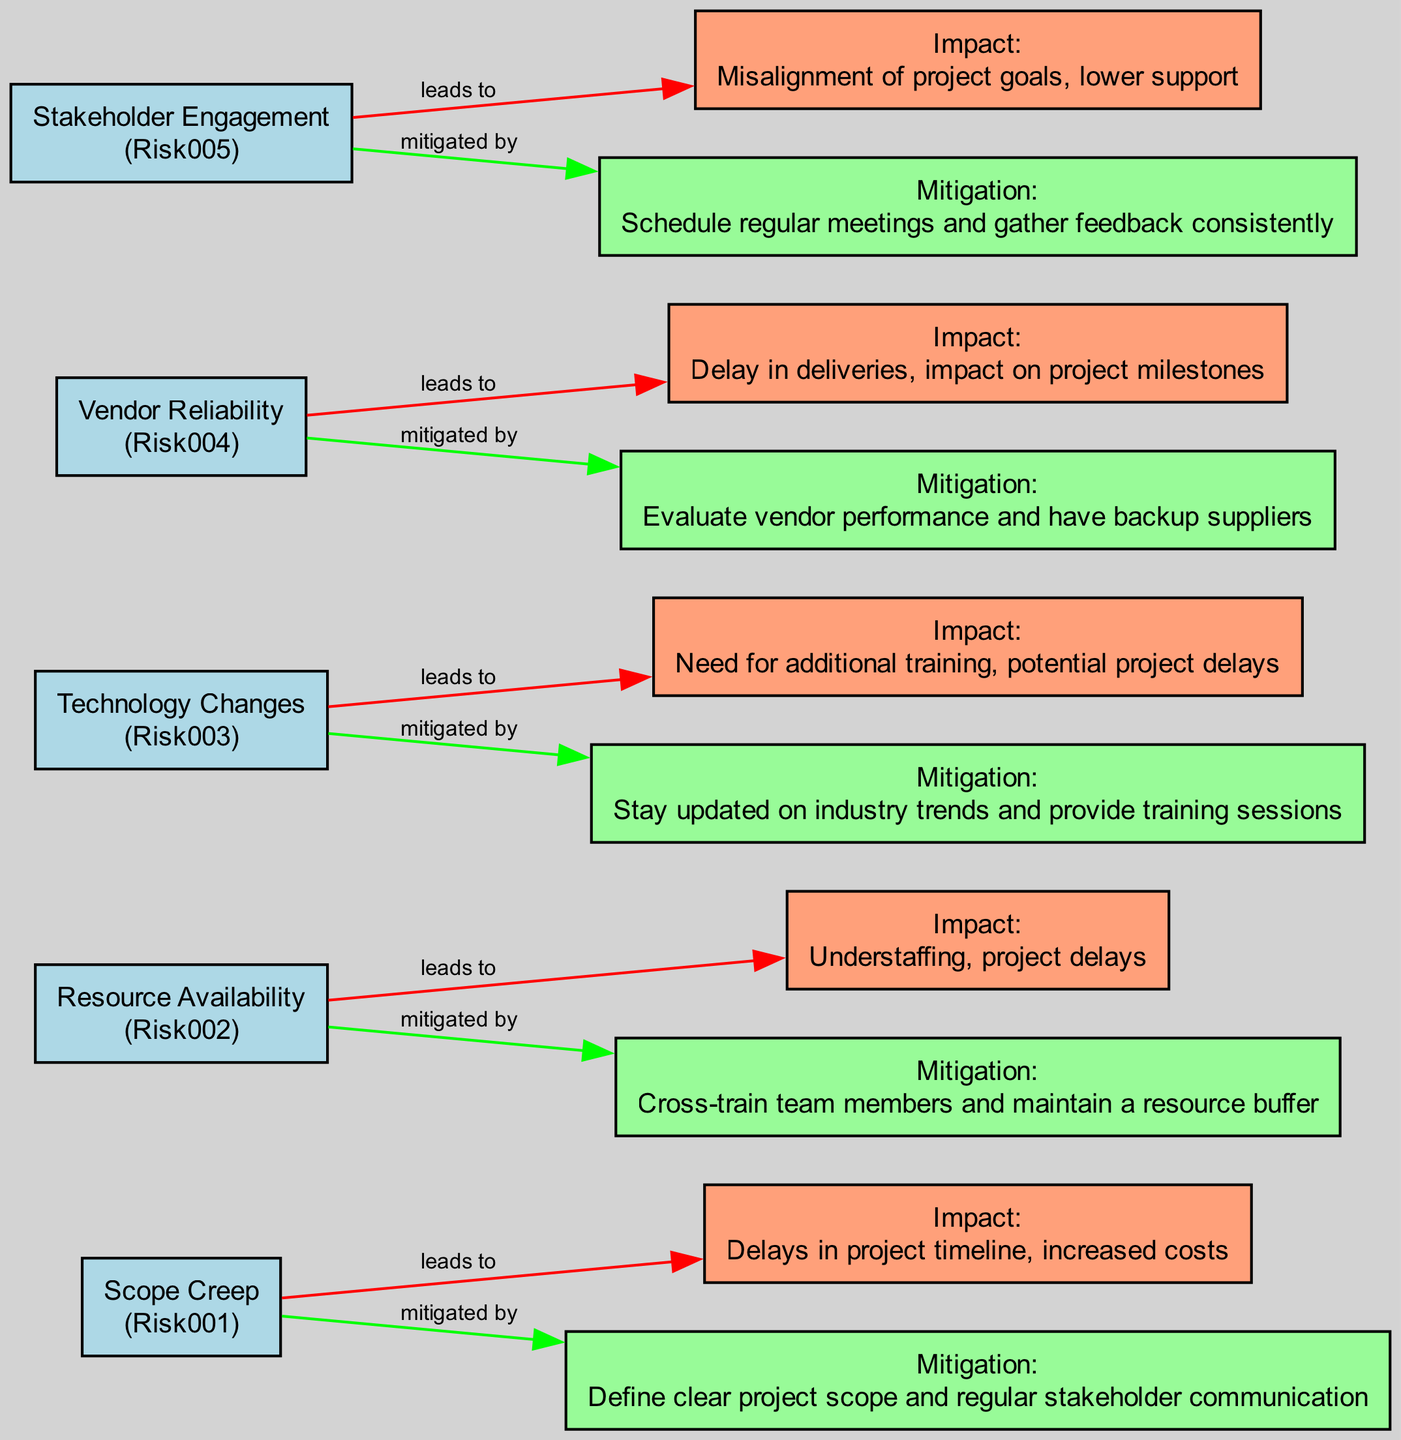What is the first identified risk in the diagram? The first identified risk node is named "Scope Creep," as it appears first in the list provided in the data.
Answer: Scope Creep How many total risks are identified in the diagram? By counting the entries in the risks section of the data, there are five distinct risks listed.
Answer: 5 What is the impact of "Technology Changes"? The impact associated with "Technology Changes" is described as "Need for additional training, potential project delays." This information is found in the node connected to the risk.
Answer: Need for additional training, potential project delays Which risk has the mitigation strategy of "Cross-train team members and maintain a resource buffer"? The mitigation strategy "Cross-train team members and maintain a resource buffer" is specifically linked to the risk identified as "Resource Availability," so you can trace back from the mitigation node to find the corresponding risk node.
Answer: Resource Availability How many edges connect to the "Scope Creep" node? The "Scope Creep" node is connected to two edges: one leading to its associated impact and another leading to its mitigation strategy. Each edge represents a relationship from the risk node to other nodes.
Answer: 2 What is the relationship between "Vendor Reliability" and its associated impact? The relationship is represented by an edge labeled "leads to," indicating that "Vendor Reliability" directly influences the identified impact of delays in deliveries and impacts on project milestones.
Answer: leads to Which risk is mitigated by the strategy of "Evaluate vendor performance and have backup suppliers"? The mitigation strategy "Evaluate vendor performance and have backup suppliers" corresponds directly to the risk "Vendor Reliability," as it is the listed mitigation for that risk.
Answer: Vendor Reliability What color represents the risks in the diagram? The risks are all represented in a light blue color within the diagram, which is specified by the fill color setting in the graph generation code.
Answer: light blue What is the main consequence of "Stakeholder Engagement"? The consequence associated with "Stakeholder Engagement" is "Misalignment of project goals, lower support," which is detailed in the impact node connected to the risk.
Answer: Misalignment of project goals, lower support 